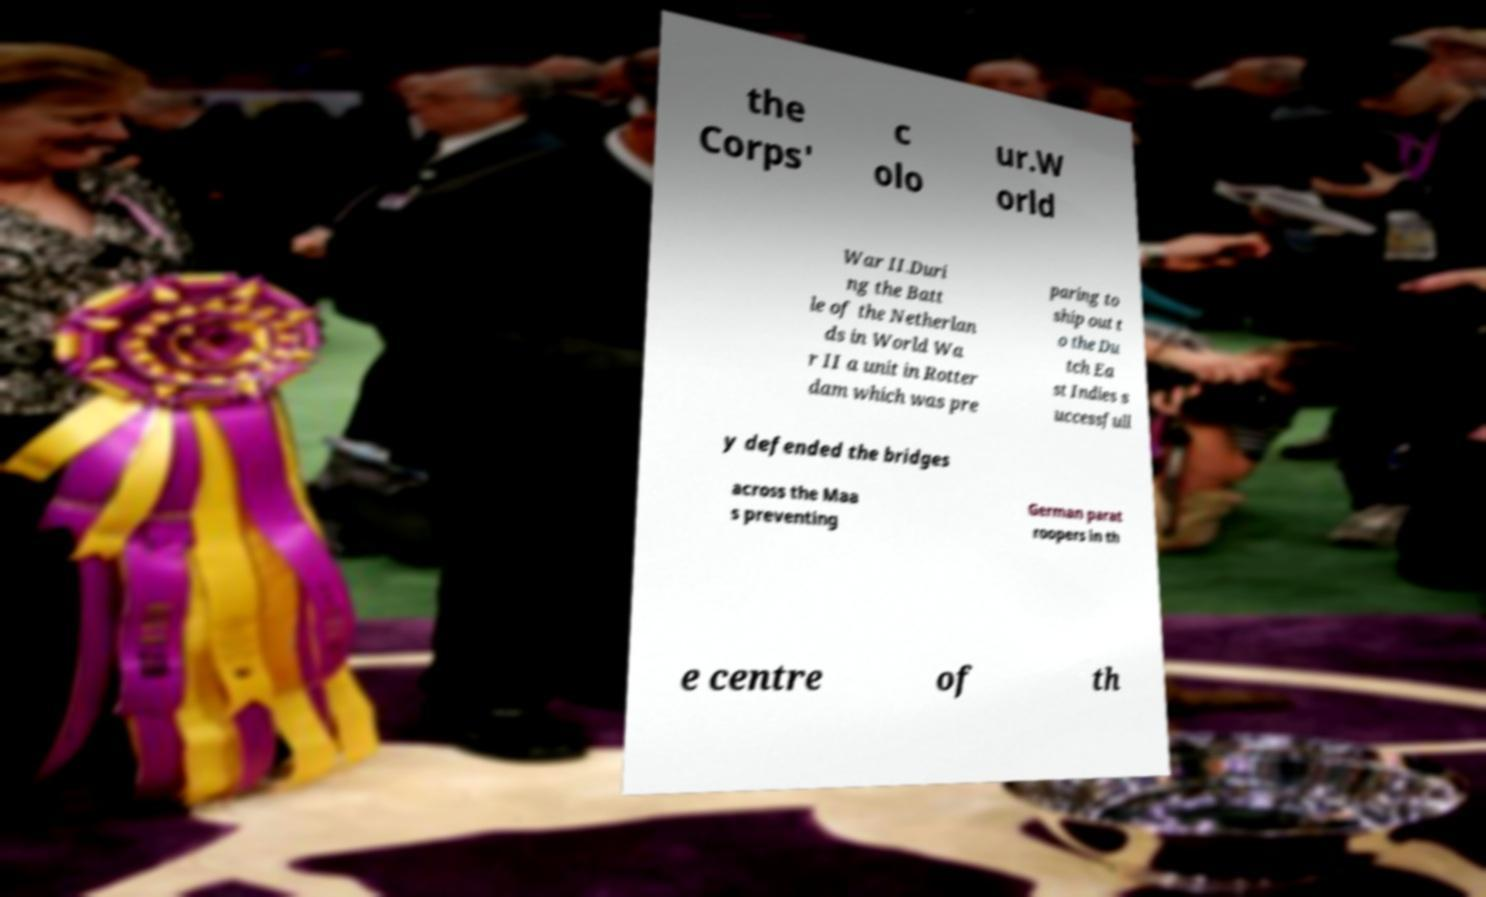Can you read and provide the text displayed in the image?This photo seems to have some interesting text. Can you extract and type it out for me? the Corps' c olo ur.W orld War II.Duri ng the Batt le of the Netherlan ds in World Wa r II a unit in Rotter dam which was pre paring to ship out t o the Du tch Ea st Indies s uccessfull y defended the bridges across the Maa s preventing German parat roopers in th e centre of th 